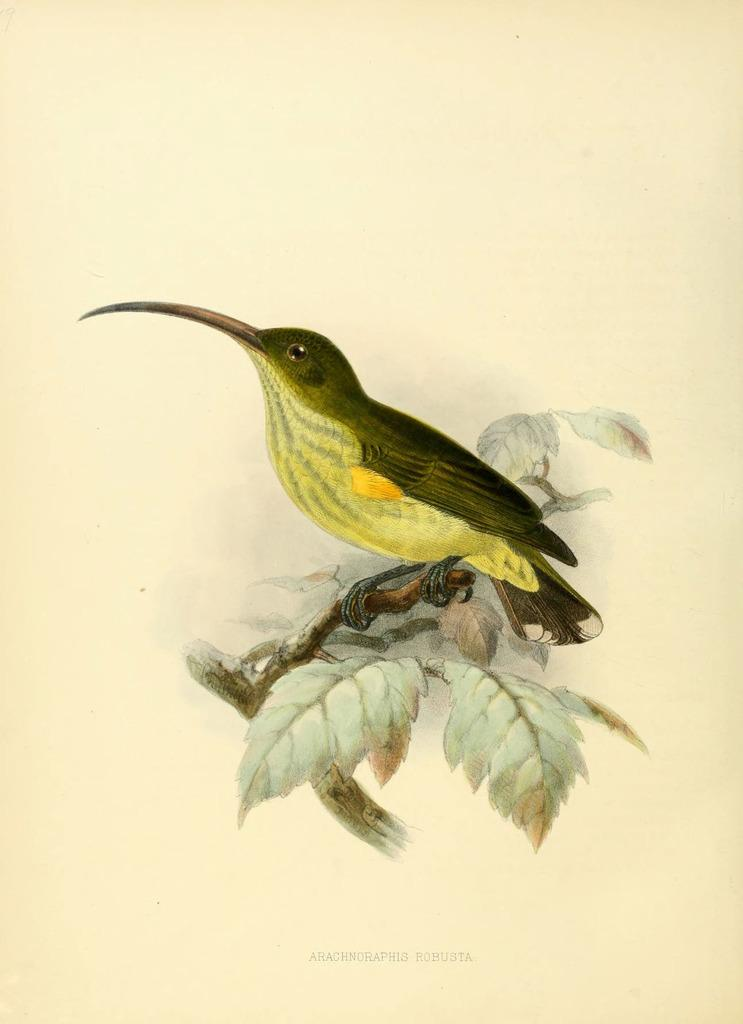What animal is depicted in the image? There is a depiction of a bird in the image. What type of vegetation is present in the image? There are leaves in the image. What color is the background of the image? The background of the image is yellow. What type of toy can be seen in the image? There is no toy present in the image. How much sand is visible in the image? There is no sand present in the image. 